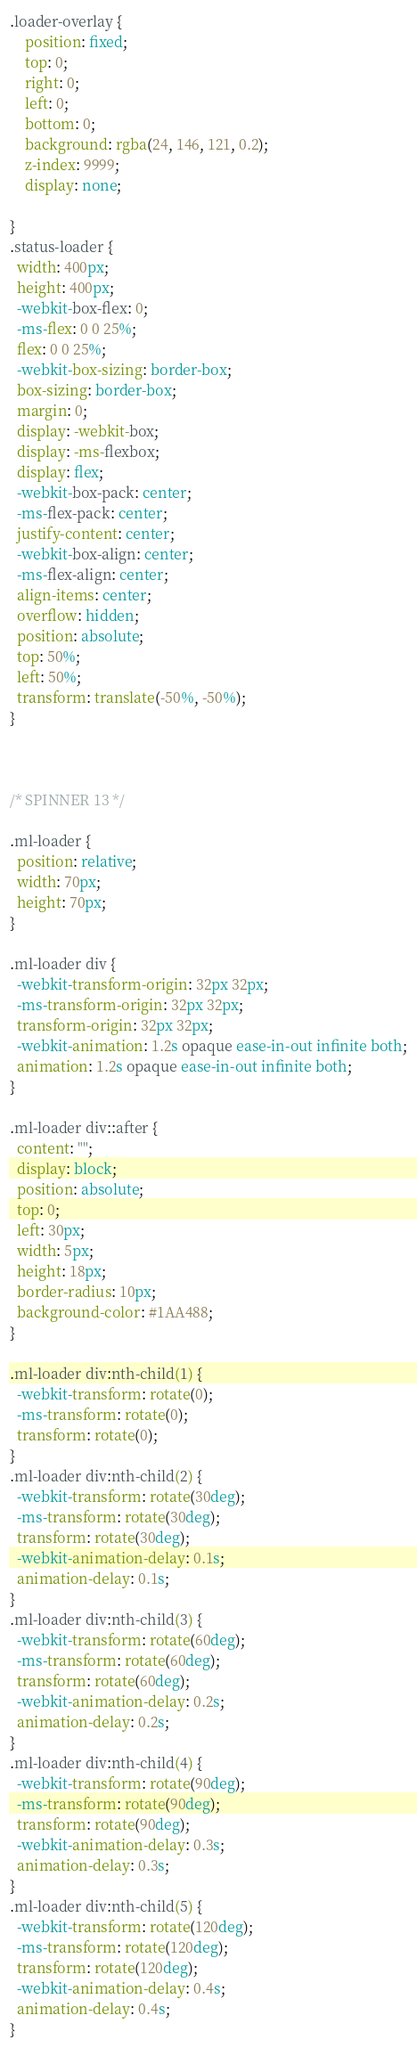Convert code to text. <code><loc_0><loc_0><loc_500><loc_500><_CSS_>.loader-overlay {
    position: fixed;
    top: 0;
    right: 0;
    left: 0;
    bottom: 0;
    background: rgba(24, 146, 121, 0.2);
    z-index: 9999;
    display: none;
    
}
.status-loader {
  width: 400px;
  height: 400px;
  -webkit-box-flex: 0;
  -ms-flex: 0 0 25%;
  flex: 0 0 25%;
  -webkit-box-sizing: border-box;
  box-sizing: border-box;
  margin: 0;
  display: -webkit-box;
  display: -ms-flexbox;
  display: flex;
  -webkit-box-pack: center;
  -ms-flex-pack: center;
  justify-content: center;
  -webkit-box-align: center;
  -ms-flex-align: center;
  align-items: center;
  overflow: hidden;
  position: absolute;
  top: 50%;
  left: 50%;
  transform: translate(-50%, -50%);
}



/* SPINNER 13 */

.ml-loader {
  position: relative;
  width: 70px;
  height: 70px;
}

.ml-loader div {
  -webkit-transform-origin: 32px 32px;
  -ms-transform-origin: 32px 32px;
  transform-origin: 32px 32px;
  -webkit-animation: 1.2s opaque ease-in-out infinite both;
  animation: 1.2s opaque ease-in-out infinite both;
}

.ml-loader div::after {
  content: "";
  display: block;
  position: absolute;
  top: 0;
  left: 30px;
  width: 5px;
  height: 18px;
  border-radius: 10px;
  background-color: #1AA488;
}

.ml-loader div:nth-child(1) {
  -webkit-transform: rotate(0);
  -ms-transform: rotate(0);
  transform: rotate(0);
}
.ml-loader div:nth-child(2) {
  -webkit-transform: rotate(30deg);
  -ms-transform: rotate(30deg);
  transform: rotate(30deg);
  -webkit-animation-delay: 0.1s;
  animation-delay: 0.1s;
}
.ml-loader div:nth-child(3) {
  -webkit-transform: rotate(60deg);
  -ms-transform: rotate(60deg);
  transform: rotate(60deg);
  -webkit-animation-delay: 0.2s;
  animation-delay: 0.2s;
}
.ml-loader div:nth-child(4) {
  -webkit-transform: rotate(90deg);
  -ms-transform: rotate(90deg);
  transform: rotate(90deg);
  -webkit-animation-delay: 0.3s;
  animation-delay: 0.3s;
}
.ml-loader div:nth-child(5) {
  -webkit-transform: rotate(120deg);
  -ms-transform: rotate(120deg);
  transform: rotate(120deg);
  -webkit-animation-delay: 0.4s;
  animation-delay: 0.4s;
}</code> 